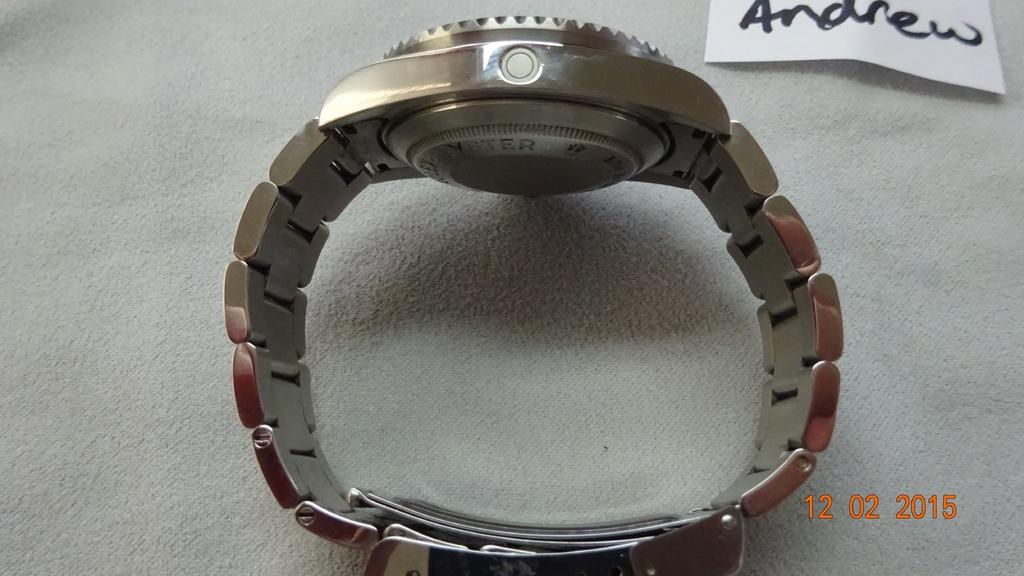What object is present in the image that is typically used for telling time? There is a watch in the image. On what surface is the watch placed? The watch is placed on a white cloth. What other item can be seen in the image besides the watch? There is a white note in the image. What name is written on the white note? The word 'andrew' is written on the white note. How many cents are visible in the image? There are no cents present in the image. What type of animal is grazing in the background of the image? There is no animal present in the image. 